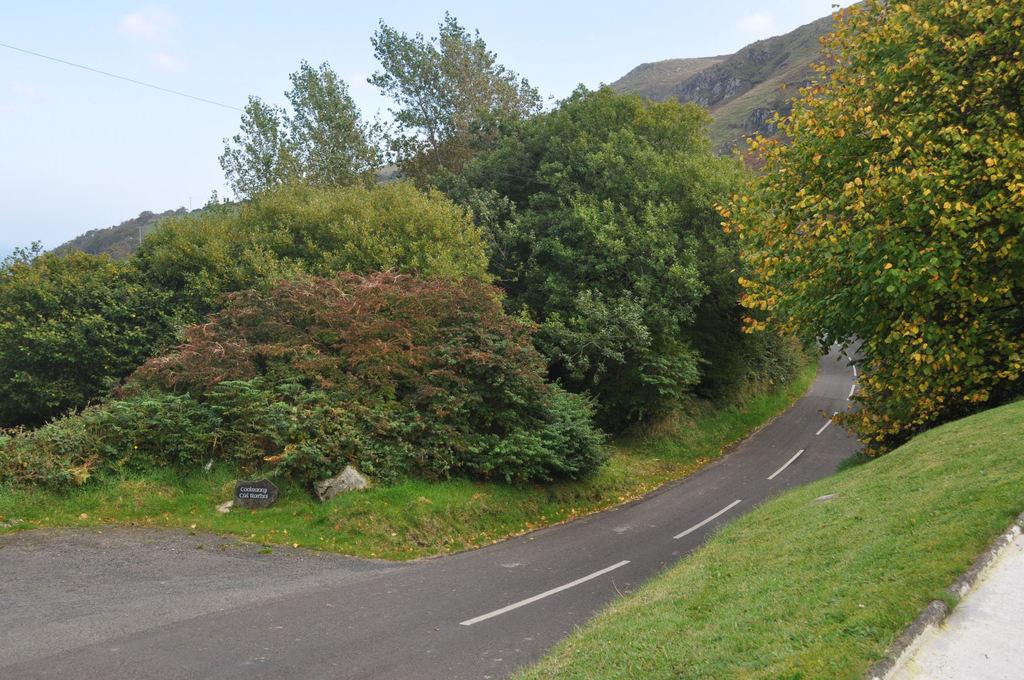What type of pathway is visible in the image? There is a road in the image. What type of vegetation can be seen in the image? There are trees, plants, and grass visible in the image. What type of terrain is present in the image? There are hills in the image. What is visible in the background of the image? The sky is visible in the background of the image. What type of cloth is draped over the trees in the image? There is no cloth present in the image; the trees are not draped with any cloth. What idea is being conveyed by the line of trees in the image? There is no specific idea being conveyed by the trees in the image; they are simply part of the landscape. 